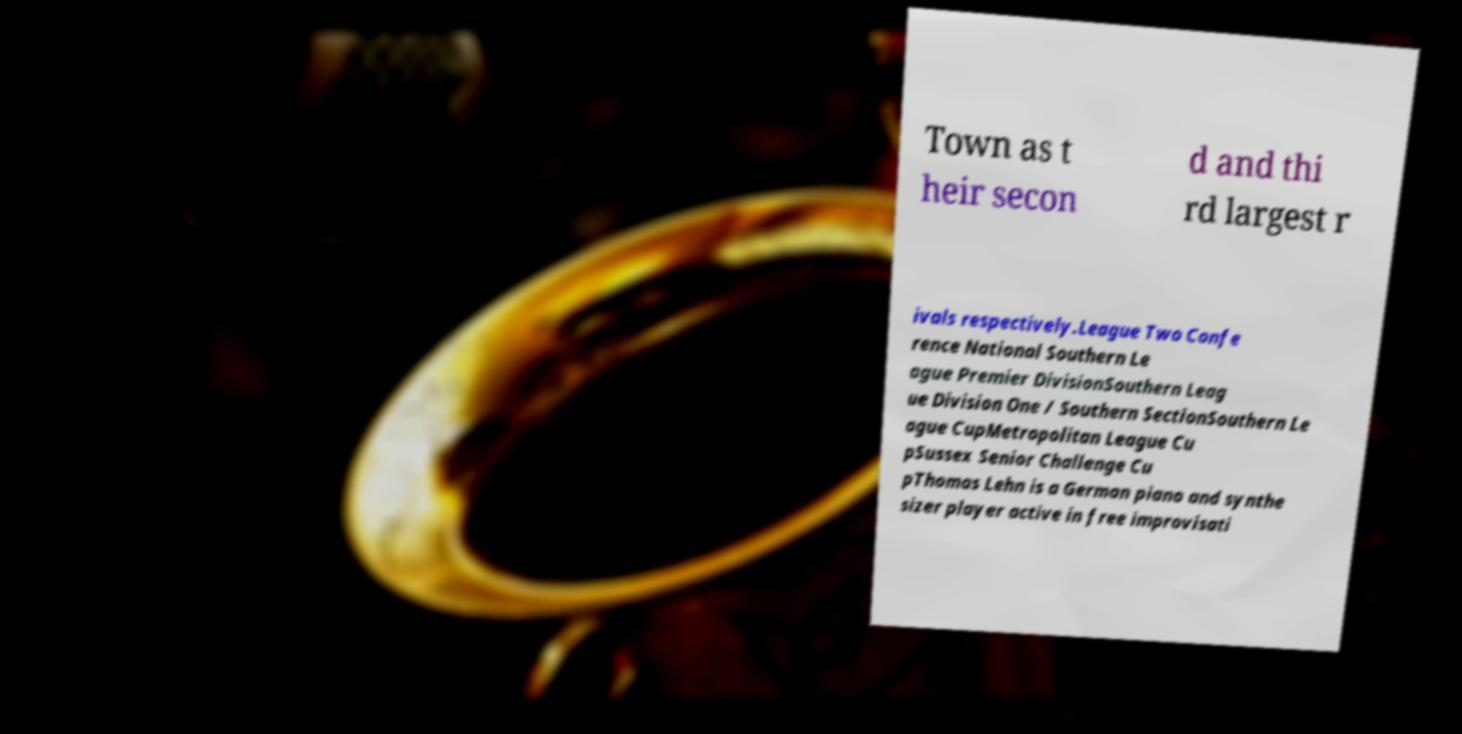Can you read and provide the text displayed in the image?This photo seems to have some interesting text. Can you extract and type it out for me? Town as t heir secon d and thi rd largest r ivals respectively.League Two Confe rence National Southern Le ague Premier DivisionSouthern Leag ue Division One / Southern SectionSouthern Le ague CupMetropolitan League Cu pSussex Senior Challenge Cu pThomas Lehn is a German piano and synthe sizer player active in free improvisati 